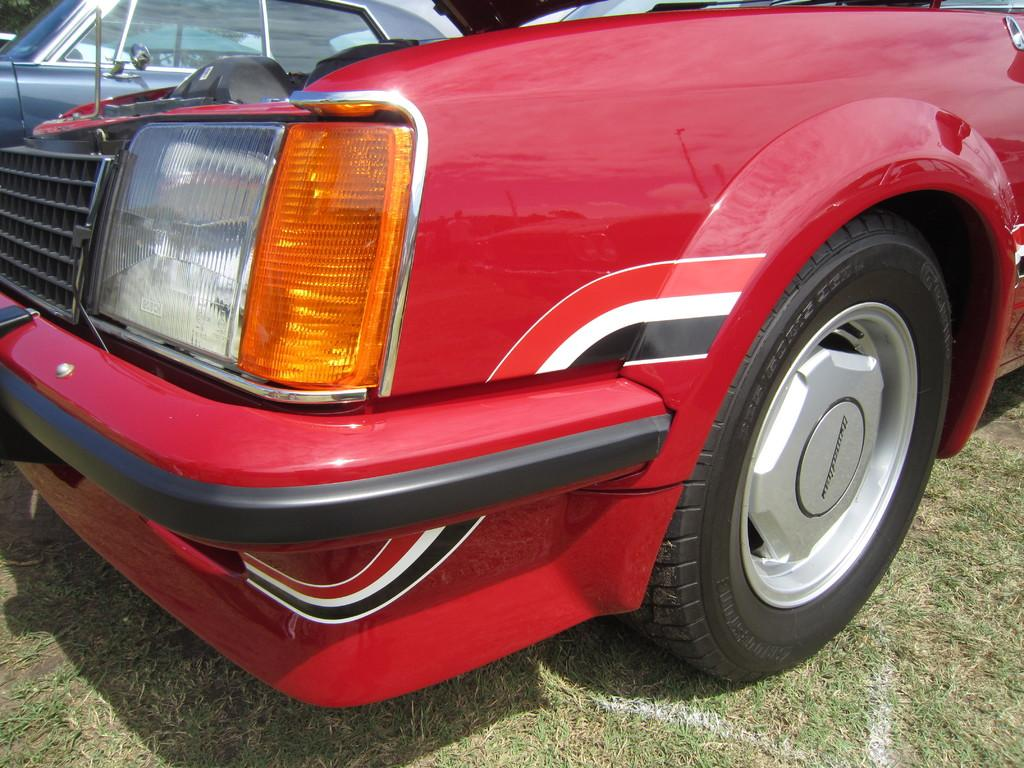What type of vehicles can be seen in the image? There are cars in the image. Where are the cars located? The cars are on the ground. What type of collar is visible on the cars in the image? There is no collar present on the cars in the image. Cars do not wear collars, as they are vehicles and not living beings. 